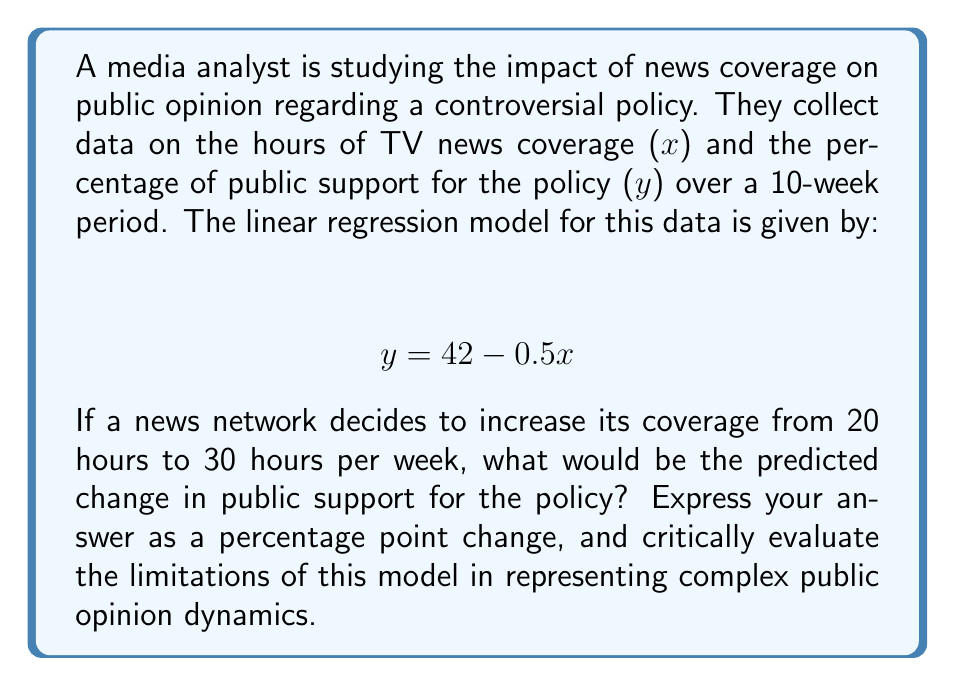Teach me how to tackle this problem. To solve this problem, we need to:

1. Understand the given linear equation:
   $$ y = 42 - 0.5x $$
   Where $y$ is the percentage of public support and $x$ is the hours of TV news coverage.

2. Calculate the predicted support at 20 hours and 30 hours of coverage:

   For 20 hours: $y_1 = 42 - 0.5(20) = 42 - 10 = 32\%$
   For 30 hours: $y_2 = 42 - 0.5(30) = 42 - 15 = 27\%$

3. Calculate the difference:
   $\Delta y = y_2 - y_1 = 27\% - 32\% = -5$ percentage points

Critically evaluating the model:

1. Linearity assumption: The model assumes a constant rate of change in public opinion per hour of coverage, which may not reflect real-world complexities.

2. Simplification: The model reduces multifaceted public opinion to a single variable, ignoring other potential influences.

3. Causality: The model implies a direct causal relationship between media coverage and public opinion, which may be an oversimplification.

4. Time factor: The model doesn't account for potential time lags in opinion shifts or cumulative effects of sustained coverage.

5. Content neutrality: The model doesn't distinguish between different types or tones of coverage, which could have varying impacts on public opinion.

6. Limits of prediction: Extrapolating beyond the observed data range may lead to unrealistic predictions.
Answer: The predicted change in public support is a decrease of 5 percentage points. However, this simplistic linear model likely overstates the direct impact of media coverage on public opinion and fails to capture the nuanced dynamics of opinion formation in a complex media landscape. 